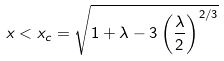<formula> <loc_0><loc_0><loc_500><loc_500>x < x _ { c } = \sqrt { 1 + \lambda - 3 \left ( \frac { \lambda } { 2 } \right ) ^ { 2 / 3 } }</formula> 